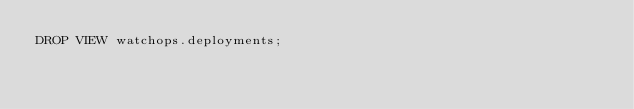<code> <loc_0><loc_0><loc_500><loc_500><_SQL_>DROP VIEW watchops.deployments;
</code> 